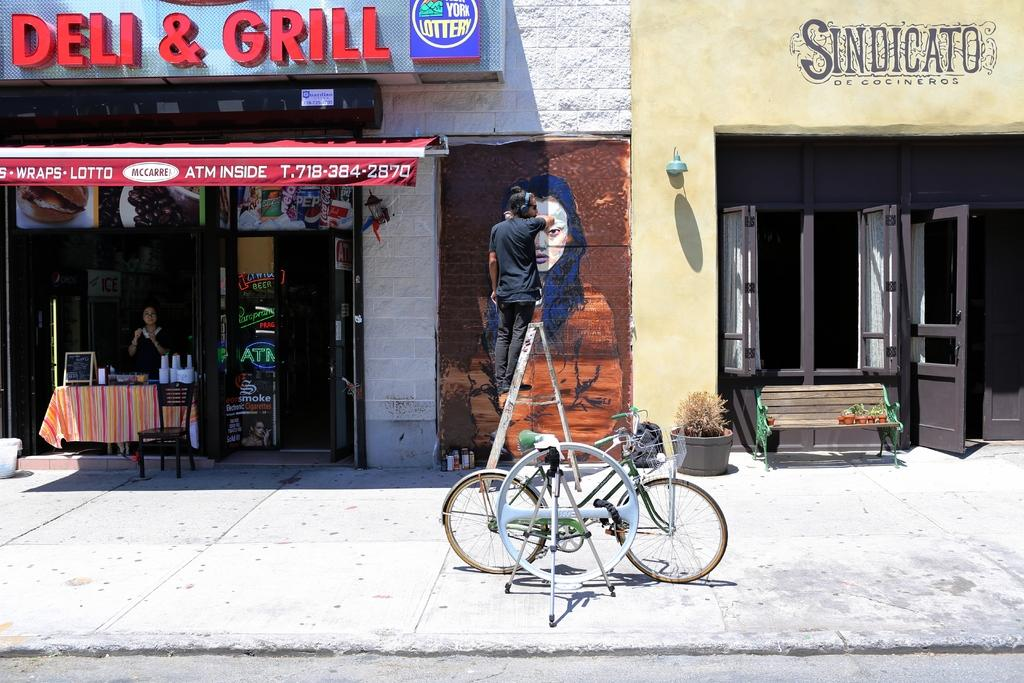What is the person in the image doing? The person is standing on a stand and painting a wall. What can be seen on either side of the person? There are stores on either side of the person. What is located behind the person? There is a cycle park behind the person. What type of clouds can be seen in the image? There are no clouds visible in the image, as it is focused on the person painting a wall and the surrounding environment. 